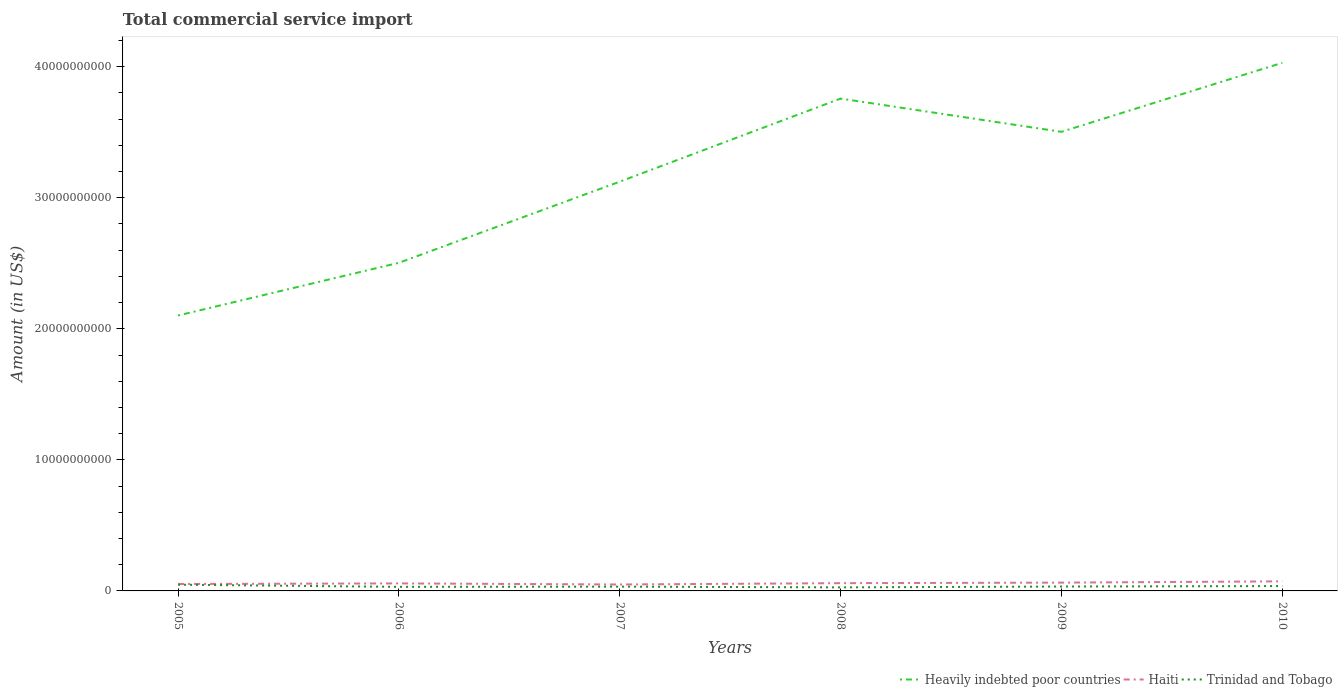How many different coloured lines are there?
Offer a terse response. 3. Across all years, what is the maximum total commercial service import in Heavily indebted poor countries?
Provide a succinct answer. 2.10e+1. What is the total total commercial service import in Heavily indebted poor countries in the graph?
Ensure brevity in your answer.  -6.34e+09. What is the difference between the highest and the second highest total commercial service import in Haiti?
Offer a terse response. 2.40e+08. What is the difference between the highest and the lowest total commercial service import in Heavily indebted poor countries?
Provide a short and direct response. 3. How many years are there in the graph?
Give a very brief answer. 6. What is the difference between two consecutive major ticks on the Y-axis?
Offer a terse response. 1.00e+1. Does the graph contain any zero values?
Your answer should be compact. No. Where does the legend appear in the graph?
Offer a terse response. Bottom right. How many legend labels are there?
Provide a short and direct response. 3. What is the title of the graph?
Ensure brevity in your answer.  Total commercial service import. What is the label or title of the Y-axis?
Offer a very short reply. Amount (in US$). What is the Amount (in US$) of Heavily indebted poor countries in 2005?
Give a very brief answer. 2.10e+1. What is the Amount (in US$) in Haiti in 2005?
Give a very brief answer. 5.28e+08. What is the Amount (in US$) in Trinidad and Tobago in 2005?
Your answer should be very brief. 4.75e+08. What is the Amount (in US$) of Heavily indebted poor countries in 2006?
Your response must be concise. 2.50e+1. What is the Amount (in US$) in Haiti in 2006?
Offer a terse response. 5.74e+08. What is the Amount (in US$) of Trinidad and Tobago in 2006?
Keep it short and to the point. 3.11e+08. What is the Amount (in US$) of Heavily indebted poor countries in 2007?
Provide a short and direct response. 3.12e+1. What is the Amount (in US$) of Haiti in 2007?
Provide a succinct answer. 4.91e+08. What is the Amount (in US$) of Trinidad and Tobago in 2007?
Provide a short and direct response. 3.27e+08. What is the Amount (in US$) in Heavily indebted poor countries in 2008?
Make the answer very short. 3.76e+1. What is the Amount (in US$) of Haiti in 2008?
Ensure brevity in your answer.  5.92e+08. What is the Amount (in US$) of Trinidad and Tobago in 2008?
Your answer should be very brief. 2.71e+08. What is the Amount (in US$) in Heavily indebted poor countries in 2009?
Your answer should be very brief. 3.50e+1. What is the Amount (in US$) in Haiti in 2009?
Give a very brief answer. 6.33e+08. What is the Amount (in US$) of Trinidad and Tobago in 2009?
Offer a very short reply. 3.35e+08. What is the Amount (in US$) in Heavily indebted poor countries in 2010?
Your answer should be very brief. 4.03e+1. What is the Amount (in US$) in Haiti in 2010?
Offer a very short reply. 7.31e+08. What is the Amount (in US$) of Trinidad and Tobago in 2010?
Your answer should be compact. 3.71e+08. Across all years, what is the maximum Amount (in US$) in Heavily indebted poor countries?
Offer a terse response. 4.03e+1. Across all years, what is the maximum Amount (in US$) of Haiti?
Offer a very short reply. 7.31e+08. Across all years, what is the maximum Amount (in US$) in Trinidad and Tobago?
Your answer should be compact. 4.75e+08. Across all years, what is the minimum Amount (in US$) in Heavily indebted poor countries?
Ensure brevity in your answer.  2.10e+1. Across all years, what is the minimum Amount (in US$) of Haiti?
Offer a terse response. 4.91e+08. Across all years, what is the minimum Amount (in US$) of Trinidad and Tobago?
Offer a very short reply. 2.71e+08. What is the total Amount (in US$) in Heavily indebted poor countries in the graph?
Your answer should be compact. 1.90e+11. What is the total Amount (in US$) in Haiti in the graph?
Offer a terse response. 3.55e+09. What is the total Amount (in US$) of Trinidad and Tobago in the graph?
Give a very brief answer. 2.09e+09. What is the difference between the Amount (in US$) of Heavily indebted poor countries in 2005 and that in 2006?
Your answer should be compact. -4.02e+09. What is the difference between the Amount (in US$) of Haiti in 2005 and that in 2006?
Offer a very short reply. -4.62e+07. What is the difference between the Amount (in US$) in Trinidad and Tobago in 2005 and that in 2006?
Your answer should be very brief. 1.64e+08. What is the difference between the Amount (in US$) in Heavily indebted poor countries in 2005 and that in 2007?
Provide a short and direct response. -1.02e+1. What is the difference between the Amount (in US$) of Haiti in 2005 and that in 2007?
Your answer should be very brief. 3.68e+07. What is the difference between the Amount (in US$) in Trinidad and Tobago in 2005 and that in 2007?
Give a very brief answer. 1.48e+08. What is the difference between the Amount (in US$) of Heavily indebted poor countries in 2005 and that in 2008?
Provide a succinct answer. -1.65e+1. What is the difference between the Amount (in US$) in Haiti in 2005 and that in 2008?
Provide a short and direct response. -6.41e+07. What is the difference between the Amount (in US$) in Trinidad and Tobago in 2005 and that in 2008?
Your answer should be very brief. 2.03e+08. What is the difference between the Amount (in US$) of Heavily indebted poor countries in 2005 and that in 2009?
Give a very brief answer. -1.40e+1. What is the difference between the Amount (in US$) in Haiti in 2005 and that in 2009?
Offer a terse response. -1.05e+08. What is the difference between the Amount (in US$) in Trinidad and Tobago in 2005 and that in 2009?
Offer a terse response. 1.40e+08. What is the difference between the Amount (in US$) in Heavily indebted poor countries in 2005 and that in 2010?
Offer a terse response. -1.93e+1. What is the difference between the Amount (in US$) of Haiti in 2005 and that in 2010?
Your answer should be compact. -2.03e+08. What is the difference between the Amount (in US$) in Trinidad and Tobago in 2005 and that in 2010?
Provide a succinct answer. 1.04e+08. What is the difference between the Amount (in US$) in Heavily indebted poor countries in 2006 and that in 2007?
Your response must be concise. -6.19e+09. What is the difference between the Amount (in US$) of Haiti in 2006 and that in 2007?
Give a very brief answer. 8.30e+07. What is the difference between the Amount (in US$) of Trinidad and Tobago in 2006 and that in 2007?
Offer a very short reply. -1.62e+07. What is the difference between the Amount (in US$) in Heavily indebted poor countries in 2006 and that in 2008?
Keep it short and to the point. -1.25e+1. What is the difference between the Amount (in US$) of Haiti in 2006 and that in 2008?
Your answer should be very brief. -1.79e+07. What is the difference between the Amount (in US$) in Trinidad and Tobago in 2006 and that in 2008?
Make the answer very short. 3.93e+07. What is the difference between the Amount (in US$) in Heavily indebted poor countries in 2006 and that in 2009?
Keep it short and to the point. -9.99e+09. What is the difference between the Amount (in US$) of Haiti in 2006 and that in 2009?
Provide a succinct answer. -5.90e+07. What is the difference between the Amount (in US$) of Trinidad and Tobago in 2006 and that in 2009?
Your answer should be very brief. -2.41e+07. What is the difference between the Amount (in US$) in Heavily indebted poor countries in 2006 and that in 2010?
Your answer should be very brief. -1.53e+1. What is the difference between the Amount (in US$) of Haiti in 2006 and that in 2010?
Your response must be concise. -1.57e+08. What is the difference between the Amount (in US$) of Trinidad and Tobago in 2006 and that in 2010?
Make the answer very short. -6.03e+07. What is the difference between the Amount (in US$) of Heavily indebted poor countries in 2007 and that in 2008?
Make the answer very short. -6.34e+09. What is the difference between the Amount (in US$) in Haiti in 2007 and that in 2008?
Your response must be concise. -1.01e+08. What is the difference between the Amount (in US$) of Trinidad and Tobago in 2007 and that in 2008?
Offer a terse response. 5.55e+07. What is the difference between the Amount (in US$) of Heavily indebted poor countries in 2007 and that in 2009?
Offer a very short reply. -3.80e+09. What is the difference between the Amount (in US$) in Haiti in 2007 and that in 2009?
Offer a very short reply. -1.42e+08. What is the difference between the Amount (in US$) of Trinidad and Tobago in 2007 and that in 2009?
Keep it short and to the point. -7.90e+06. What is the difference between the Amount (in US$) of Heavily indebted poor countries in 2007 and that in 2010?
Keep it short and to the point. -9.07e+09. What is the difference between the Amount (in US$) in Haiti in 2007 and that in 2010?
Your answer should be very brief. -2.40e+08. What is the difference between the Amount (in US$) in Trinidad and Tobago in 2007 and that in 2010?
Keep it short and to the point. -4.41e+07. What is the difference between the Amount (in US$) of Heavily indebted poor countries in 2008 and that in 2009?
Your answer should be compact. 2.54e+09. What is the difference between the Amount (in US$) of Haiti in 2008 and that in 2009?
Your response must be concise. -4.11e+07. What is the difference between the Amount (in US$) of Trinidad and Tobago in 2008 and that in 2009?
Provide a short and direct response. -6.34e+07. What is the difference between the Amount (in US$) of Heavily indebted poor countries in 2008 and that in 2010?
Make the answer very short. -2.73e+09. What is the difference between the Amount (in US$) in Haiti in 2008 and that in 2010?
Your answer should be very brief. -1.39e+08. What is the difference between the Amount (in US$) of Trinidad and Tobago in 2008 and that in 2010?
Provide a short and direct response. -9.96e+07. What is the difference between the Amount (in US$) in Heavily indebted poor countries in 2009 and that in 2010?
Make the answer very short. -5.27e+09. What is the difference between the Amount (in US$) in Haiti in 2009 and that in 2010?
Offer a very short reply. -9.79e+07. What is the difference between the Amount (in US$) in Trinidad and Tobago in 2009 and that in 2010?
Your answer should be compact. -3.62e+07. What is the difference between the Amount (in US$) in Heavily indebted poor countries in 2005 and the Amount (in US$) in Haiti in 2006?
Your answer should be very brief. 2.04e+1. What is the difference between the Amount (in US$) of Heavily indebted poor countries in 2005 and the Amount (in US$) of Trinidad and Tobago in 2006?
Keep it short and to the point. 2.07e+1. What is the difference between the Amount (in US$) of Haiti in 2005 and the Amount (in US$) of Trinidad and Tobago in 2006?
Make the answer very short. 2.17e+08. What is the difference between the Amount (in US$) in Heavily indebted poor countries in 2005 and the Amount (in US$) in Haiti in 2007?
Make the answer very short. 2.05e+1. What is the difference between the Amount (in US$) of Heavily indebted poor countries in 2005 and the Amount (in US$) of Trinidad and Tobago in 2007?
Offer a very short reply. 2.07e+1. What is the difference between the Amount (in US$) in Haiti in 2005 and the Amount (in US$) in Trinidad and Tobago in 2007?
Make the answer very short. 2.01e+08. What is the difference between the Amount (in US$) of Heavily indebted poor countries in 2005 and the Amount (in US$) of Haiti in 2008?
Your response must be concise. 2.04e+1. What is the difference between the Amount (in US$) in Heavily indebted poor countries in 2005 and the Amount (in US$) in Trinidad and Tobago in 2008?
Provide a short and direct response. 2.07e+1. What is the difference between the Amount (in US$) in Haiti in 2005 and the Amount (in US$) in Trinidad and Tobago in 2008?
Make the answer very short. 2.57e+08. What is the difference between the Amount (in US$) in Heavily indebted poor countries in 2005 and the Amount (in US$) in Haiti in 2009?
Your answer should be very brief. 2.04e+1. What is the difference between the Amount (in US$) in Heavily indebted poor countries in 2005 and the Amount (in US$) in Trinidad and Tobago in 2009?
Make the answer very short. 2.07e+1. What is the difference between the Amount (in US$) in Haiti in 2005 and the Amount (in US$) in Trinidad and Tobago in 2009?
Your answer should be compact. 1.93e+08. What is the difference between the Amount (in US$) in Heavily indebted poor countries in 2005 and the Amount (in US$) in Haiti in 2010?
Ensure brevity in your answer.  2.03e+1. What is the difference between the Amount (in US$) in Heavily indebted poor countries in 2005 and the Amount (in US$) in Trinidad and Tobago in 2010?
Ensure brevity in your answer.  2.06e+1. What is the difference between the Amount (in US$) of Haiti in 2005 and the Amount (in US$) of Trinidad and Tobago in 2010?
Give a very brief answer. 1.57e+08. What is the difference between the Amount (in US$) in Heavily indebted poor countries in 2006 and the Amount (in US$) in Haiti in 2007?
Your answer should be compact. 2.45e+1. What is the difference between the Amount (in US$) of Heavily indebted poor countries in 2006 and the Amount (in US$) of Trinidad and Tobago in 2007?
Give a very brief answer. 2.47e+1. What is the difference between the Amount (in US$) of Haiti in 2006 and the Amount (in US$) of Trinidad and Tobago in 2007?
Provide a short and direct response. 2.47e+08. What is the difference between the Amount (in US$) of Heavily indebted poor countries in 2006 and the Amount (in US$) of Haiti in 2008?
Give a very brief answer. 2.44e+1. What is the difference between the Amount (in US$) of Heavily indebted poor countries in 2006 and the Amount (in US$) of Trinidad and Tobago in 2008?
Ensure brevity in your answer.  2.48e+1. What is the difference between the Amount (in US$) in Haiti in 2006 and the Amount (in US$) in Trinidad and Tobago in 2008?
Ensure brevity in your answer.  3.03e+08. What is the difference between the Amount (in US$) of Heavily indebted poor countries in 2006 and the Amount (in US$) of Haiti in 2009?
Keep it short and to the point. 2.44e+1. What is the difference between the Amount (in US$) of Heavily indebted poor countries in 2006 and the Amount (in US$) of Trinidad and Tobago in 2009?
Provide a short and direct response. 2.47e+1. What is the difference between the Amount (in US$) of Haiti in 2006 and the Amount (in US$) of Trinidad and Tobago in 2009?
Your response must be concise. 2.39e+08. What is the difference between the Amount (in US$) of Heavily indebted poor countries in 2006 and the Amount (in US$) of Haiti in 2010?
Provide a short and direct response. 2.43e+1. What is the difference between the Amount (in US$) in Heavily indebted poor countries in 2006 and the Amount (in US$) in Trinidad and Tobago in 2010?
Make the answer very short. 2.47e+1. What is the difference between the Amount (in US$) in Haiti in 2006 and the Amount (in US$) in Trinidad and Tobago in 2010?
Provide a succinct answer. 2.03e+08. What is the difference between the Amount (in US$) of Heavily indebted poor countries in 2007 and the Amount (in US$) of Haiti in 2008?
Offer a very short reply. 3.06e+1. What is the difference between the Amount (in US$) in Heavily indebted poor countries in 2007 and the Amount (in US$) in Trinidad and Tobago in 2008?
Keep it short and to the point. 3.10e+1. What is the difference between the Amount (in US$) of Haiti in 2007 and the Amount (in US$) of Trinidad and Tobago in 2008?
Keep it short and to the point. 2.20e+08. What is the difference between the Amount (in US$) of Heavily indebted poor countries in 2007 and the Amount (in US$) of Haiti in 2009?
Offer a very short reply. 3.06e+1. What is the difference between the Amount (in US$) in Heavily indebted poor countries in 2007 and the Amount (in US$) in Trinidad and Tobago in 2009?
Give a very brief answer. 3.09e+1. What is the difference between the Amount (in US$) in Haiti in 2007 and the Amount (in US$) in Trinidad and Tobago in 2009?
Your answer should be compact. 1.56e+08. What is the difference between the Amount (in US$) in Heavily indebted poor countries in 2007 and the Amount (in US$) in Haiti in 2010?
Your answer should be compact. 3.05e+1. What is the difference between the Amount (in US$) of Heavily indebted poor countries in 2007 and the Amount (in US$) of Trinidad and Tobago in 2010?
Offer a very short reply. 3.09e+1. What is the difference between the Amount (in US$) in Haiti in 2007 and the Amount (in US$) in Trinidad and Tobago in 2010?
Provide a succinct answer. 1.20e+08. What is the difference between the Amount (in US$) in Heavily indebted poor countries in 2008 and the Amount (in US$) in Haiti in 2009?
Ensure brevity in your answer.  3.69e+1. What is the difference between the Amount (in US$) of Heavily indebted poor countries in 2008 and the Amount (in US$) of Trinidad and Tobago in 2009?
Your answer should be compact. 3.72e+1. What is the difference between the Amount (in US$) of Haiti in 2008 and the Amount (in US$) of Trinidad and Tobago in 2009?
Make the answer very short. 2.57e+08. What is the difference between the Amount (in US$) in Heavily indebted poor countries in 2008 and the Amount (in US$) in Haiti in 2010?
Provide a succinct answer. 3.68e+1. What is the difference between the Amount (in US$) in Heavily indebted poor countries in 2008 and the Amount (in US$) in Trinidad and Tobago in 2010?
Ensure brevity in your answer.  3.72e+1. What is the difference between the Amount (in US$) of Haiti in 2008 and the Amount (in US$) of Trinidad and Tobago in 2010?
Keep it short and to the point. 2.21e+08. What is the difference between the Amount (in US$) in Heavily indebted poor countries in 2009 and the Amount (in US$) in Haiti in 2010?
Keep it short and to the point. 3.43e+1. What is the difference between the Amount (in US$) of Heavily indebted poor countries in 2009 and the Amount (in US$) of Trinidad and Tobago in 2010?
Make the answer very short. 3.47e+1. What is the difference between the Amount (in US$) in Haiti in 2009 and the Amount (in US$) in Trinidad and Tobago in 2010?
Give a very brief answer. 2.62e+08. What is the average Amount (in US$) of Heavily indebted poor countries per year?
Offer a very short reply. 3.17e+1. What is the average Amount (in US$) in Haiti per year?
Your answer should be compact. 5.92e+08. What is the average Amount (in US$) of Trinidad and Tobago per year?
Ensure brevity in your answer.  3.48e+08. In the year 2005, what is the difference between the Amount (in US$) of Heavily indebted poor countries and Amount (in US$) of Haiti?
Provide a short and direct response. 2.05e+1. In the year 2005, what is the difference between the Amount (in US$) in Heavily indebted poor countries and Amount (in US$) in Trinidad and Tobago?
Make the answer very short. 2.05e+1. In the year 2005, what is the difference between the Amount (in US$) in Haiti and Amount (in US$) in Trinidad and Tobago?
Offer a terse response. 5.34e+07. In the year 2006, what is the difference between the Amount (in US$) of Heavily indebted poor countries and Amount (in US$) of Haiti?
Give a very brief answer. 2.45e+1. In the year 2006, what is the difference between the Amount (in US$) of Heavily indebted poor countries and Amount (in US$) of Trinidad and Tobago?
Give a very brief answer. 2.47e+1. In the year 2006, what is the difference between the Amount (in US$) in Haiti and Amount (in US$) in Trinidad and Tobago?
Make the answer very short. 2.64e+08. In the year 2007, what is the difference between the Amount (in US$) in Heavily indebted poor countries and Amount (in US$) in Haiti?
Keep it short and to the point. 3.07e+1. In the year 2007, what is the difference between the Amount (in US$) in Heavily indebted poor countries and Amount (in US$) in Trinidad and Tobago?
Ensure brevity in your answer.  3.09e+1. In the year 2007, what is the difference between the Amount (in US$) of Haiti and Amount (in US$) of Trinidad and Tobago?
Provide a succinct answer. 1.64e+08. In the year 2008, what is the difference between the Amount (in US$) in Heavily indebted poor countries and Amount (in US$) in Haiti?
Make the answer very short. 3.70e+1. In the year 2008, what is the difference between the Amount (in US$) of Heavily indebted poor countries and Amount (in US$) of Trinidad and Tobago?
Provide a short and direct response. 3.73e+1. In the year 2008, what is the difference between the Amount (in US$) of Haiti and Amount (in US$) of Trinidad and Tobago?
Your answer should be very brief. 3.21e+08. In the year 2009, what is the difference between the Amount (in US$) of Heavily indebted poor countries and Amount (in US$) of Haiti?
Your response must be concise. 3.44e+1. In the year 2009, what is the difference between the Amount (in US$) of Heavily indebted poor countries and Amount (in US$) of Trinidad and Tobago?
Provide a short and direct response. 3.47e+1. In the year 2009, what is the difference between the Amount (in US$) of Haiti and Amount (in US$) of Trinidad and Tobago?
Your answer should be compact. 2.98e+08. In the year 2010, what is the difference between the Amount (in US$) of Heavily indebted poor countries and Amount (in US$) of Haiti?
Your response must be concise. 3.96e+1. In the year 2010, what is the difference between the Amount (in US$) in Heavily indebted poor countries and Amount (in US$) in Trinidad and Tobago?
Your answer should be very brief. 3.99e+1. In the year 2010, what is the difference between the Amount (in US$) in Haiti and Amount (in US$) in Trinidad and Tobago?
Your answer should be compact. 3.60e+08. What is the ratio of the Amount (in US$) in Heavily indebted poor countries in 2005 to that in 2006?
Your answer should be very brief. 0.84. What is the ratio of the Amount (in US$) in Haiti in 2005 to that in 2006?
Make the answer very short. 0.92. What is the ratio of the Amount (in US$) in Trinidad and Tobago in 2005 to that in 2006?
Provide a succinct answer. 1.53. What is the ratio of the Amount (in US$) in Heavily indebted poor countries in 2005 to that in 2007?
Your response must be concise. 0.67. What is the ratio of the Amount (in US$) of Haiti in 2005 to that in 2007?
Your response must be concise. 1.07. What is the ratio of the Amount (in US$) of Trinidad and Tobago in 2005 to that in 2007?
Your answer should be very brief. 1.45. What is the ratio of the Amount (in US$) in Heavily indebted poor countries in 2005 to that in 2008?
Ensure brevity in your answer.  0.56. What is the ratio of the Amount (in US$) in Haiti in 2005 to that in 2008?
Ensure brevity in your answer.  0.89. What is the ratio of the Amount (in US$) of Trinidad and Tobago in 2005 to that in 2008?
Your answer should be compact. 1.75. What is the ratio of the Amount (in US$) of Heavily indebted poor countries in 2005 to that in 2009?
Your response must be concise. 0.6. What is the ratio of the Amount (in US$) in Haiti in 2005 to that in 2009?
Offer a very short reply. 0.83. What is the ratio of the Amount (in US$) of Trinidad and Tobago in 2005 to that in 2009?
Your answer should be very brief. 1.42. What is the ratio of the Amount (in US$) of Heavily indebted poor countries in 2005 to that in 2010?
Provide a succinct answer. 0.52. What is the ratio of the Amount (in US$) of Haiti in 2005 to that in 2010?
Make the answer very short. 0.72. What is the ratio of the Amount (in US$) in Trinidad and Tobago in 2005 to that in 2010?
Offer a very short reply. 1.28. What is the ratio of the Amount (in US$) in Heavily indebted poor countries in 2006 to that in 2007?
Give a very brief answer. 0.8. What is the ratio of the Amount (in US$) in Haiti in 2006 to that in 2007?
Keep it short and to the point. 1.17. What is the ratio of the Amount (in US$) in Trinidad and Tobago in 2006 to that in 2007?
Your answer should be very brief. 0.95. What is the ratio of the Amount (in US$) in Heavily indebted poor countries in 2006 to that in 2008?
Ensure brevity in your answer.  0.67. What is the ratio of the Amount (in US$) of Haiti in 2006 to that in 2008?
Give a very brief answer. 0.97. What is the ratio of the Amount (in US$) in Trinidad and Tobago in 2006 to that in 2008?
Provide a short and direct response. 1.14. What is the ratio of the Amount (in US$) in Heavily indebted poor countries in 2006 to that in 2009?
Make the answer very short. 0.71. What is the ratio of the Amount (in US$) in Haiti in 2006 to that in 2009?
Make the answer very short. 0.91. What is the ratio of the Amount (in US$) of Trinidad and Tobago in 2006 to that in 2009?
Keep it short and to the point. 0.93. What is the ratio of the Amount (in US$) of Heavily indebted poor countries in 2006 to that in 2010?
Offer a very short reply. 0.62. What is the ratio of the Amount (in US$) in Haiti in 2006 to that in 2010?
Your answer should be compact. 0.79. What is the ratio of the Amount (in US$) in Trinidad and Tobago in 2006 to that in 2010?
Keep it short and to the point. 0.84. What is the ratio of the Amount (in US$) in Heavily indebted poor countries in 2007 to that in 2008?
Your answer should be compact. 0.83. What is the ratio of the Amount (in US$) in Haiti in 2007 to that in 2008?
Keep it short and to the point. 0.83. What is the ratio of the Amount (in US$) in Trinidad and Tobago in 2007 to that in 2008?
Your answer should be very brief. 1.2. What is the ratio of the Amount (in US$) in Heavily indebted poor countries in 2007 to that in 2009?
Provide a short and direct response. 0.89. What is the ratio of the Amount (in US$) in Haiti in 2007 to that in 2009?
Your response must be concise. 0.78. What is the ratio of the Amount (in US$) in Trinidad and Tobago in 2007 to that in 2009?
Ensure brevity in your answer.  0.98. What is the ratio of the Amount (in US$) in Heavily indebted poor countries in 2007 to that in 2010?
Provide a succinct answer. 0.77. What is the ratio of the Amount (in US$) of Haiti in 2007 to that in 2010?
Keep it short and to the point. 0.67. What is the ratio of the Amount (in US$) in Trinidad and Tobago in 2007 to that in 2010?
Ensure brevity in your answer.  0.88. What is the ratio of the Amount (in US$) of Heavily indebted poor countries in 2008 to that in 2009?
Give a very brief answer. 1.07. What is the ratio of the Amount (in US$) in Haiti in 2008 to that in 2009?
Your response must be concise. 0.94. What is the ratio of the Amount (in US$) of Trinidad and Tobago in 2008 to that in 2009?
Give a very brief answer. 0.81. What is the ratio of the Amount (in US$) in Heavily indebted poor countries in 2008 to that in 2010?
Offer a very short reply. 0.93. What is the ratio of the Amount (in US$) of Haiti in 2008 to that in 2010?
Give a very brief answer. 0.81. What is the ratio of the Amount (in US$) in Trinidad and Tobago in 2008 to that in 2010?
Offer a terse response. 0.73. What is the ratio of the Amount (in US$) in Heavily indebted poor countries in 2009 to that in 2010?
Your answer should be compact. 0.87. What is the ratio of the Amount (in US$) of Haiti in 2009 to that in 2010?
Keep it short and to the point. 0.87. What is the ratio of the Amount (in US$) of Trinidad and Tobago in 2009 to that in 2010?
Keep it short and to the point. 0.9. What is the difference between the highest and the second highest Amount (in US$) of Heavily indebted poor countries?
Keep it short and to the point. 2.73e+09. What is the difference between the highest and the second highest Amount (in US$) in Haiti?
Your response must be concise. 9.79e+07. What is the difference between the highest and the second highest Amount (in US$) of Trinidad and Tobago?
Provide a short and direct response. 1.04e+08. What is the difference between the highest and the lowest Amount (in US$) of Heavily indebted poor countries?
Provide a succinct answer. 1.93e+1. What is the difference between the highest and the lowest Amount (in US$) of Haiti?
Provide a short and direct response. 2.40e+08. What is the difference between the highest and the lowest Amount (in US$) of Trinidad and Tobago?
Provide a short and direct response. 2.03e+08. 